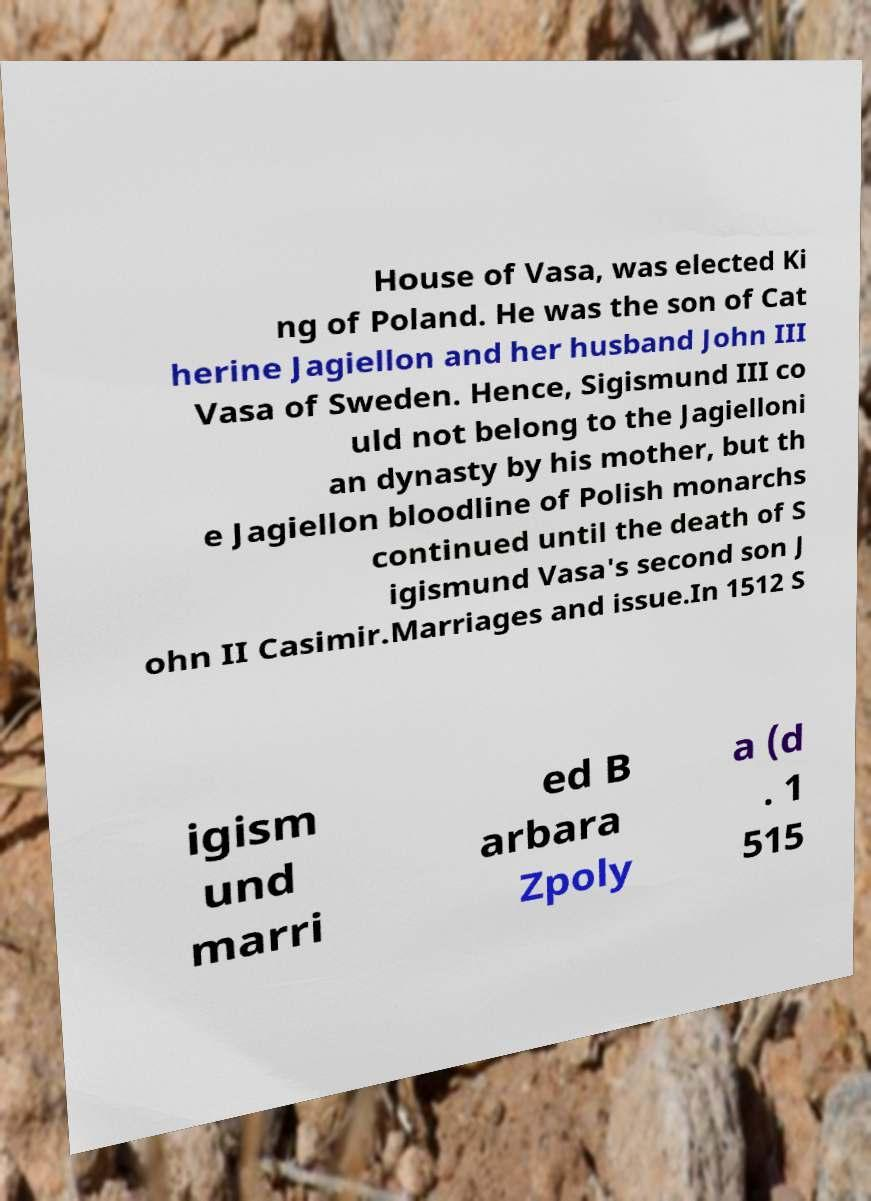Could you extract and type out the text from this image? House of Vasa, was elected Ki ng of Poland. He was the son of Cat herine Jagiellon and her husband John III Vasa of Sweden. Hence, Sigismund III co uld not belong to the Jagielloni an dynasty by his mother, but th e Jagiellon bloodline of Polish monarchs continued until the death of S igismund Vasa's second son J ohn II Casimir.Marriages and issue.In 1512 S igism und marri ed B arbara Zpoly a (d . 1 515 